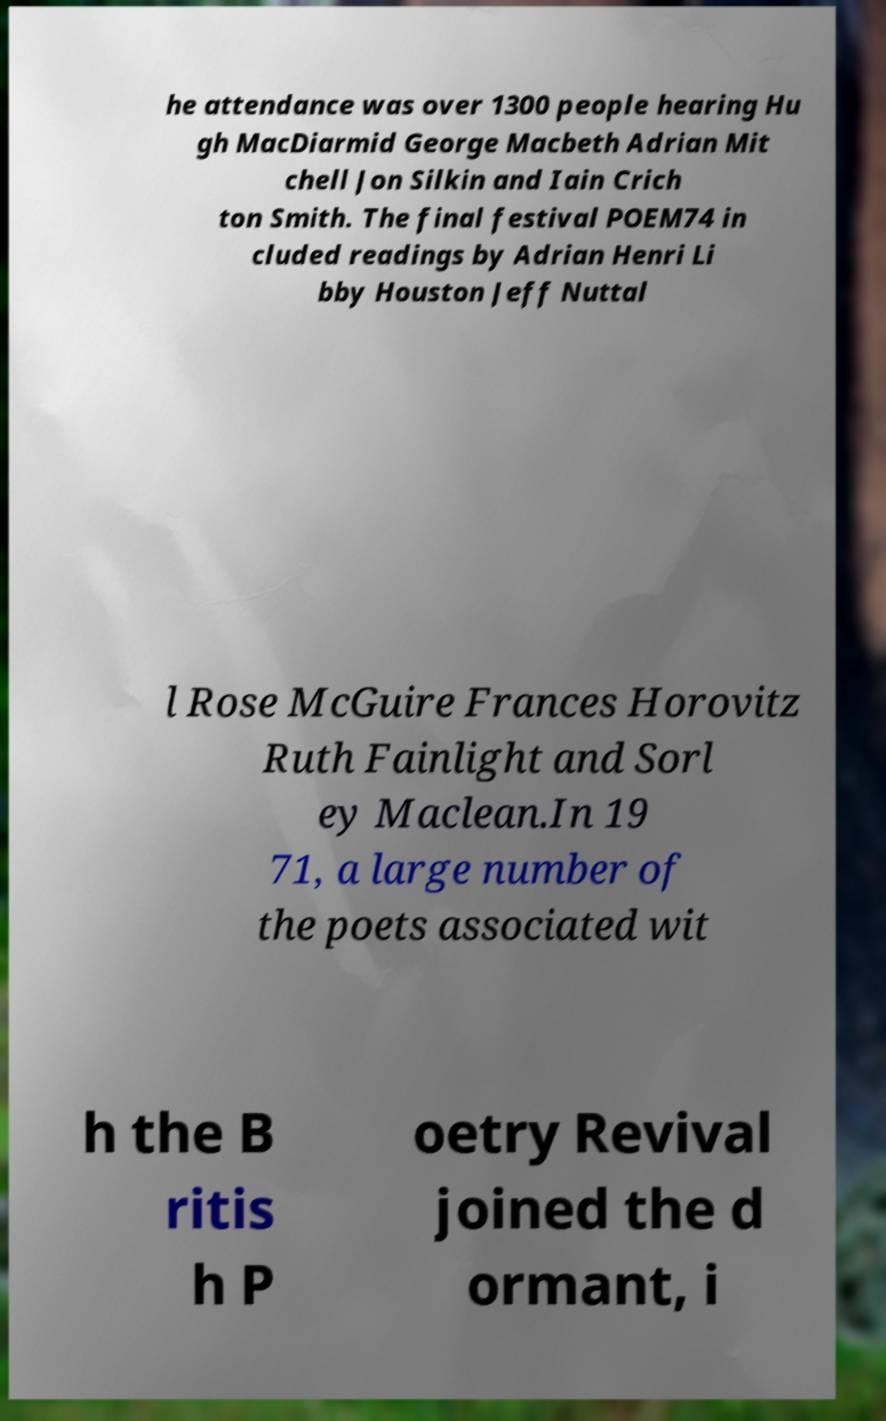Please identify and transcribe the text found in this image. he attendance was over 1300 people hearing Hu gh MacDiarmid George Macbeth Adrian Mit chell Jon Silkin and Iain Crich ton Smith. The final festival POEM74 in cluded readings by Adrian Henri Li bby Houston Jeff Nuttal l Rose McGuire Frances Horovitz Ruth Fainlight and Sorl ey Maclean.In 19 71, a large number of the poets associated wit h the B ritis h P oetry Revival joined the d ormant, i 